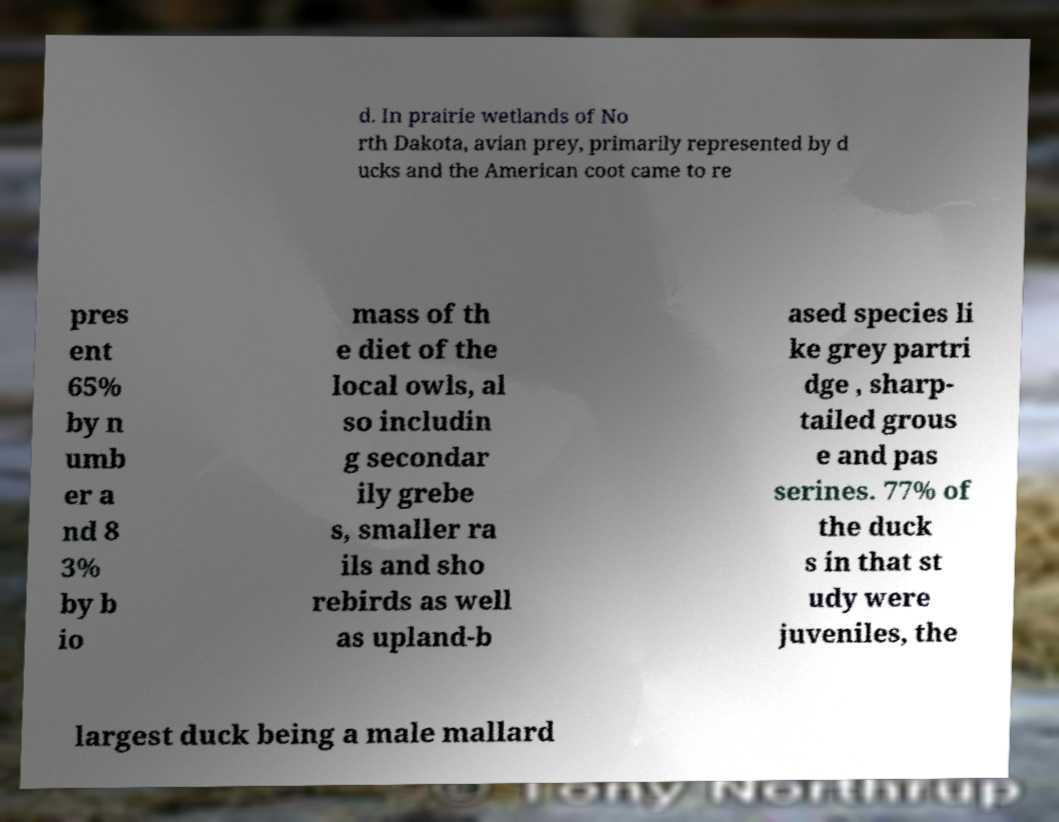For documentation purposes, I need the text within this image transcribed. Could you provide that? d. In prairie wetlands of No rth Dakota, avian prey, primarily represented by d ucks and the American coot came to re pres ent 65% by n umb er a nd 8 3% by b io mass of th e diet of the local owls, al so includin g secondar ily grebe s, smaller ra ils and sho rebirds as well as upland-b ased species li ke grey partri dge , sharp- tailed grous e and pas serines. 77% of the duck s in that st udy were juveniles, the largest duck being a male mallard 